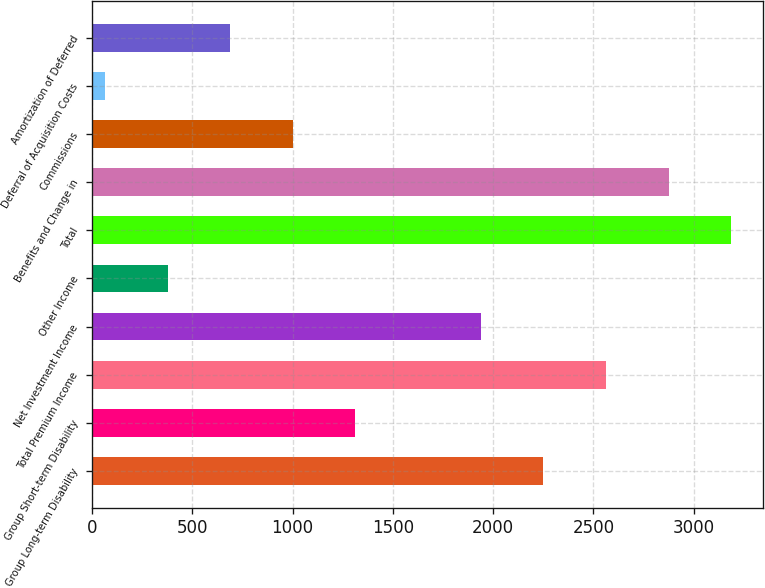<chart> <loc_0><loc_0><loc_500><loc_500><bar_chart><fcel>Group Long-term Disability<fcel>Group Short-term Disability<fcel>Total Premium Income<fcel>Net Investment Income<fcel>Other Income<fcel>Total<fcel>Benefits and Change in<fcel>Commissions<fcel>Deferral of Acquisition Costs<fcel>Amortization of Deferred<nl><fcel>2250.74<fcel>1313.78<fcel>2563.06<fcel>1938.42<fcel>376.82<fcel>3187.7<fcel>2875.38<fcel>1001.46<fcel>64.5<fcel>689.14<nl></chart> 